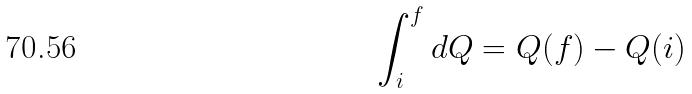Convert formula to latex. <formula><loc_0><loc_0><loc_500><loc_500>\int _ { i } ^ { f } d Q = Q ( f ) - Q ( i )</formula> 